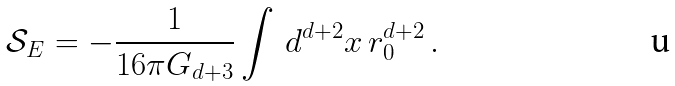Convert formula to latex. <formula><loc_0><loc_0><loc_500><loc_500>\mathcal { S } _ { E } = - \frac { 1 } { 1 6 \pi G _ { d + 3 } } \int \, d ^ { d + 2 } x \, r _ { 0 } ^ { d + 2 } \, .</formula> 